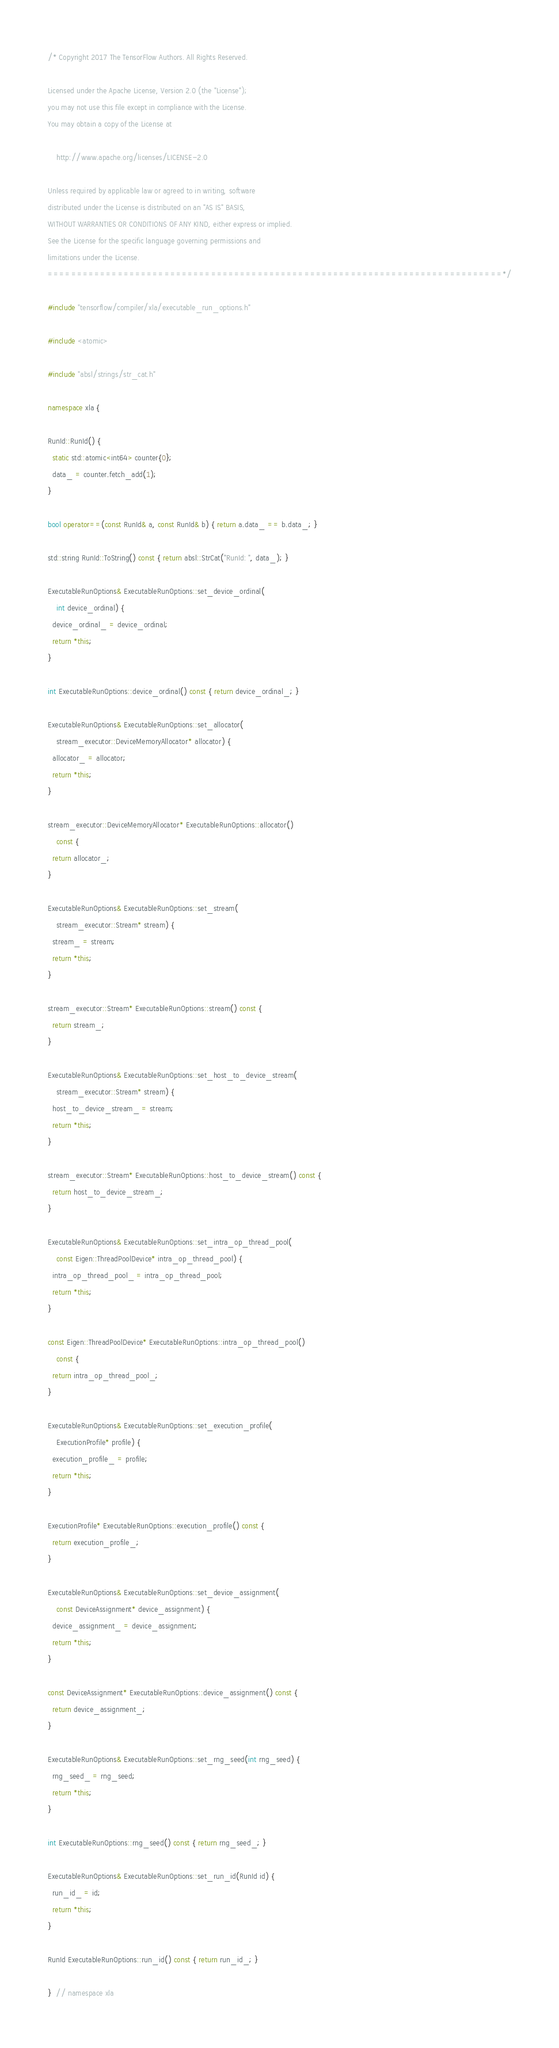<code> <loc_0><loc_0><loc_500><loc_500><_C++_>/* Copyright 2017 The TensorFlow Authors. All Rights Reserved.

Licensed under the Apache License, Version 2.0 (the "License");
you may not use this file except in compliance with the License.
You may obtain a copy of the License at

    http://www.apache.org/licenses/LICENSE-2.0

Unless required by applicable law or agreed to in writing, software
distributed under the License is distributed on an "AS IS" BASIS,
WITHOUT WARRANTIES OR CONDITIONS OF ANY KIND, either express or implied.
See the License for the specific language governing permissions and
limitations under the License.
==============================================================================*/

#include "tensorflow/compiler/xla/executable_run_options.h"

#include <atomic>

#include "absl/strings/str_cat.h"

namespace xla {

RunId::RunId() {
  static std::atomic<int64> counter{0};
  data_ = counter.fetch_add(1);
}

bool operator==(const RunId& a, const RunId& b) { return a.data_ == b.data_; }

std::string RunId::ToString() const { return absl::StrCat("RunId: ", data_); }

ExecutableRunOptions& ExecutableRunOptions::set_device_ordinal(
    int device_ordinal) {
  device_ordinal_ = device_ordinal;
  return *this;
}

int ExecutableRunOptions::device_ordinal() const { return device_ordinal_; }

ExecutableRunOptions& ExecutableRunOptions::set_allocator(
    stream_executor::DeviceMemoryAllocator* allocator) {
  allocator_ = allocator;
  return *this;
}

stream_executor::DeviceMemoryAllocator* ExecutableRunOptions::allocator()
    const {
  return allocator_;
}

ExecutableRunOptions& ExecutableRunOptions::set_stream(
    stream_executor::Stream* stream) {
  stream_ = stream;
  return *this;
}

stream_executor::Stream* ExecutableRunOptions::stream() const {
  return stream_;
}

ExecutableRunOptions& ExecutableRunOptions::set_host_to_device_stream(
    stream_executor::Stream* stream) {
  host_to_device_stream_ = stream;
  return *this;
}

stream_executor::Stream* ExecutableRunOptions::host_to_device_stream() const {
  return host_to_device_stream_;
}

ExecutableRunOptions& ExecutableRunOptions::set_intra_op_thread_pool(
    const Eigen::ThreadPoolDevice* intra_op_thread_pool) {
  intra_op_thread_pool_ = intra_op_thread_pool;
  return *this;
}

const Eigen::ThreadPoolDevice* ExecutableRunOptions::intra_op_thread_pool()
    const {
  return intra_op_thread_pool_;
}

ExecutableRunOptions& ExecutableRunOptions::set_execution_profile(
    ExecutionProfile* profile) {
  execution_profile_ = profile;
  return *this;
}

ExecutionProfile* ExecutableRunOptions::execution_profile() const {
  return execution_profile_;
}

ExecutableRunOptions& ExecutableRunOptions::set_device_assignment(
    const DeviceAssignment* device_assignment) {
  device_assignment_ = device_assignment;
  return *this;
}

const DeviceAssignment* ExecutableRunOptions::device_assignment() const {
  return device_assignment_;
}

ExecutableRunOptions& ExecutableRunOptions::set_rng_seed(int rng_seed) {
  rng_seed_ = rng_seed;
  return *this;
}

int ExecutableRunOptions::rng_seed() const { return rng_seed_; }

ExecutableRunOptions& ExecutableRunOptions::set_run_id(RunId id) {
  run_id_ = id;
  return *this;
}

RunId ExecutableRunOptions::run_id() const { return run_id_; }

}  // namespace xla
</code> 